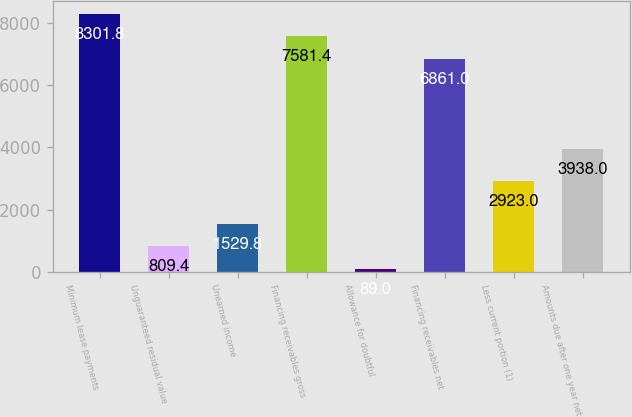Convert chart to OTSL. <chart><loc_0><loc_0><loc_500><loc_500><bar_chart><fcel>Minimum lease payments<fcel>Unguaranteed residual value<fcel>Unearned income<fcel>Financing receivables gross<fcel>Allowance for doubtful<fcel>Financing receivables net<fcel>Less current portion (1)<fcel>Amounts due after one year net<nl><fcel>8301.8<fcel>809.4<fcel>1529.8<fcel>7581.4<fcel>89<fcel>6861<fcel>2923<fcel>3938<nl></chart> 